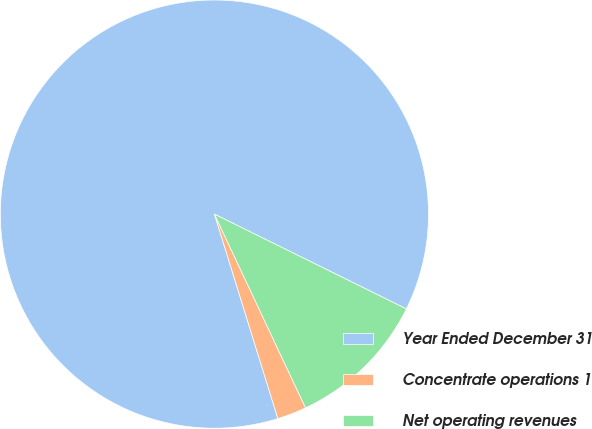Convert chart. <chart><loc_0><loc_0><loc_500><loc_500><pie_chart><fcel>Year Ended December 31<fcel>Concentrate operations 1<fcel>Net operating revenues<nl><fcel>87.09%<fcel>2.21%<fcel>10.7%<nl></chart> 